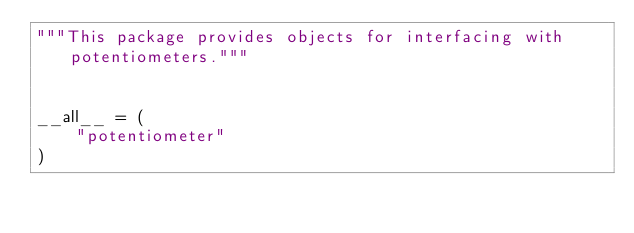<code> <loc_0><loc_0><loc_500><loc_500><_Python_>"""This package provides objects for interfacing with potentiometers."""


__all__ = (
    "potentiometer"
)
</code> 